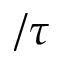<formula> <loc_0><loc_0><loc_500><loc_500>/ \tau</formula> 